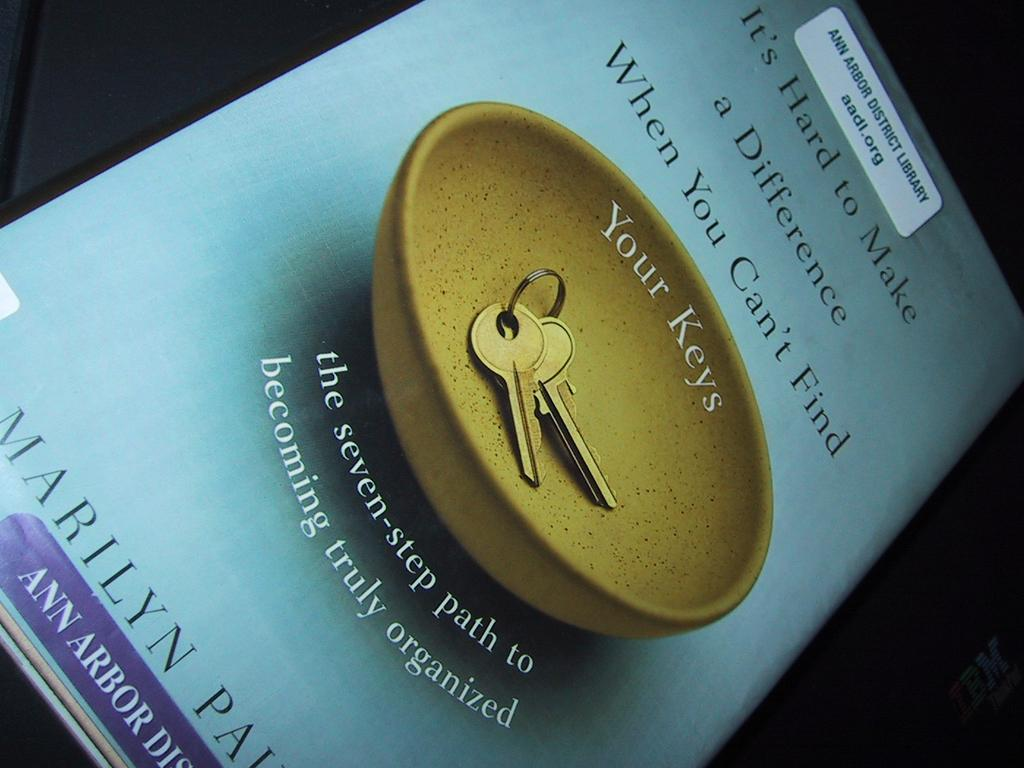<image>
Present a compact description of the photo's key features. A blue book titled It's Hard to Make a Difference When You Can't Find Your Keys 